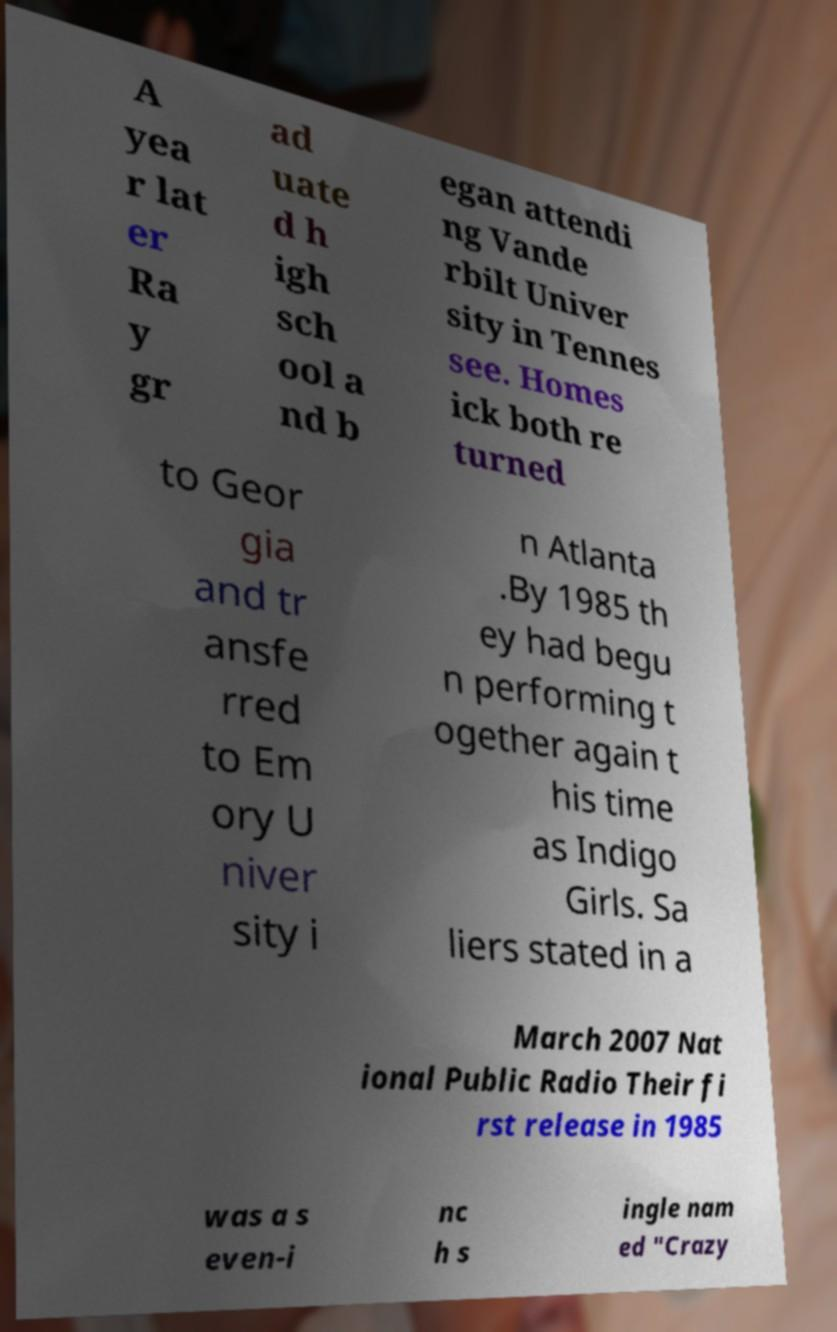Can you read and provide the text displayed in the image?This photo seems to have some interesting text. Can you extract and type it out for me? A yea r lat er Ra y gr ad uate d h igh sch ool a nd b egan attendi ng Vande rbilt Univer sity in Tennes see. Homes ick both re turned to Geor gia and tr ansfe rred to Em ory U niver sity i n Atlanta .By 1985 th ey had begu n performing t ogether again t his time as Indigo Girls. Sa liers stated in a March 2007 Nat ional Public Radio Their fi rst release in 1985 was a s even-i nc h s ingle nam ed "Crazy 